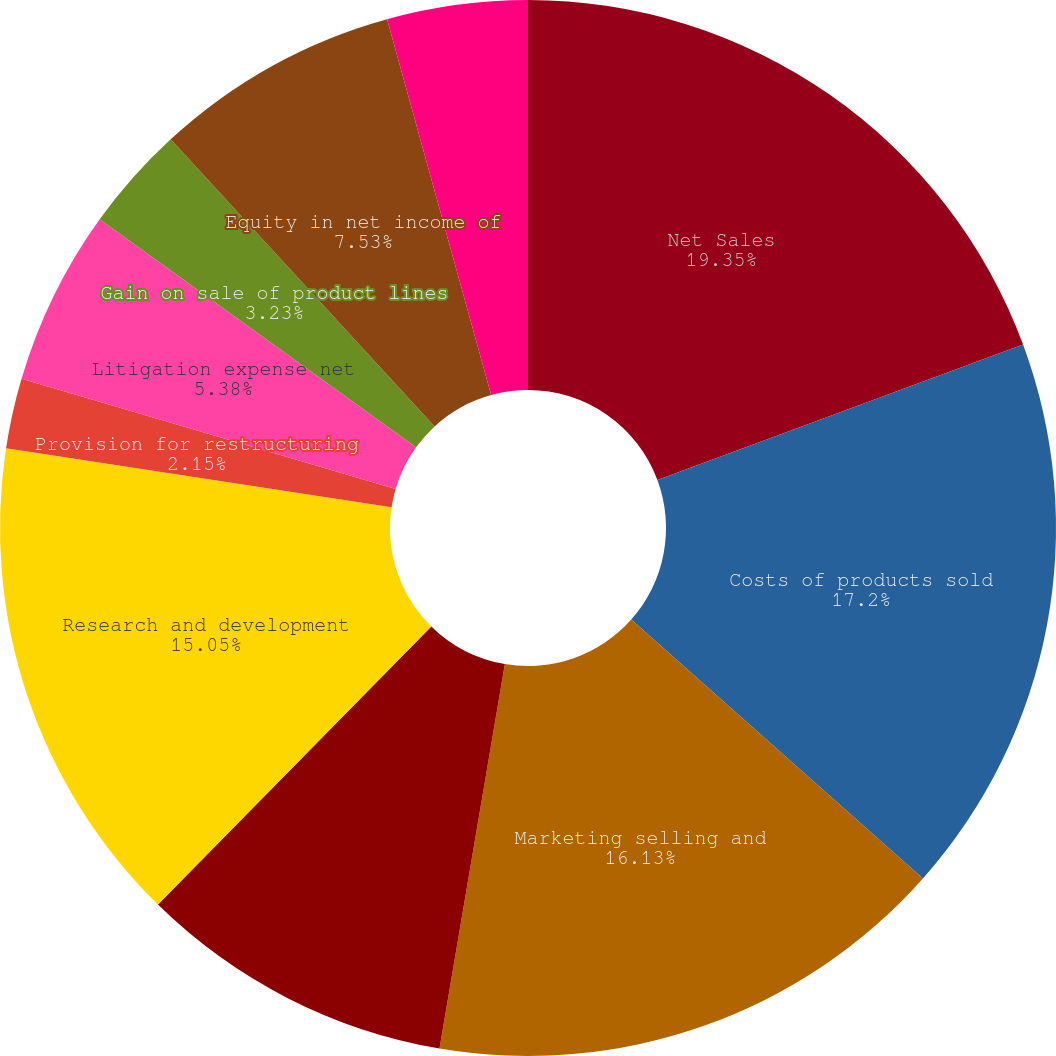Convert chart to OTSL. <chart><loc_0><loc_0><loc_500><loc_500><pie_chart><fcel>Net Sales<fcel>Costs of products sold<fcel>Marketing selling and<fcel>Advertising and product<fcel>Research and development<fcel>Provision for restructuring<fcel>Litigation expense net<fcel>Gain on sale of product lines<fcel>Equity in net income of<fcel>Other expense net<nl><fcel>19.35%<fcel>17.2%<fcel>16.13%<fcel>9.68%<fcel>15.05%<fcel>2.15%<fcel>5.38%<fcel>3.23%<fcel>7.53%<fcel>4.3%<nl></chart> 